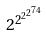Convert formula to latex. <formula><loc_0><loc_0><loc_500><loc_500>2 ^ { 2 ^ { 2 ^ { 2 ^ { 7 4 } } } }</formula> 